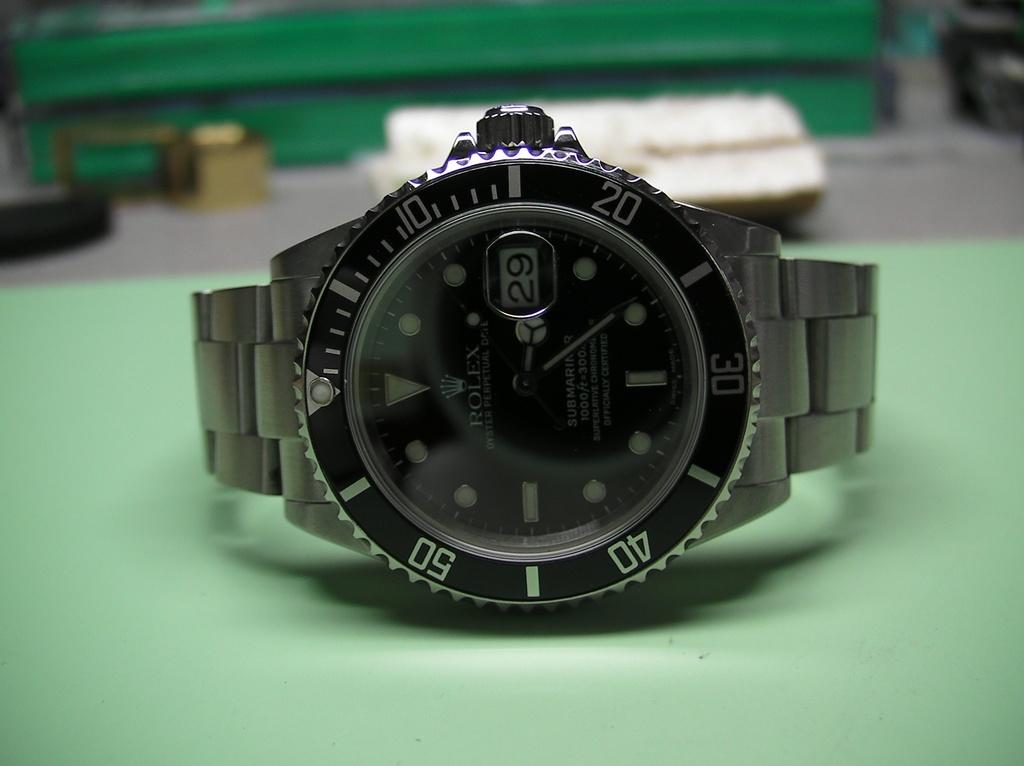What day of the month is shown on the watch?
Keep it short and to the point. 29. What brand of watch is that?
Offer a very short reply. Rolex. 